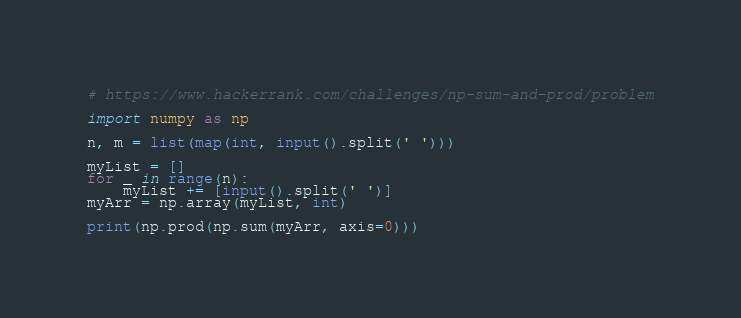Convert code to text. <code><loc_0><loc_0><loc_500><loc_500><_Python_># https://www.hackerrank.com/challenges/np-sum-and-prod/problem

import numpy as np

n, m = list(map(int, input().split(' ')))

myList = []
for _ in range(n):
    myList += [input().split(' ')]
myArr = np.array(myList, int)

print(np.prod(np.sum(myArr, axis=0)))
</code> 